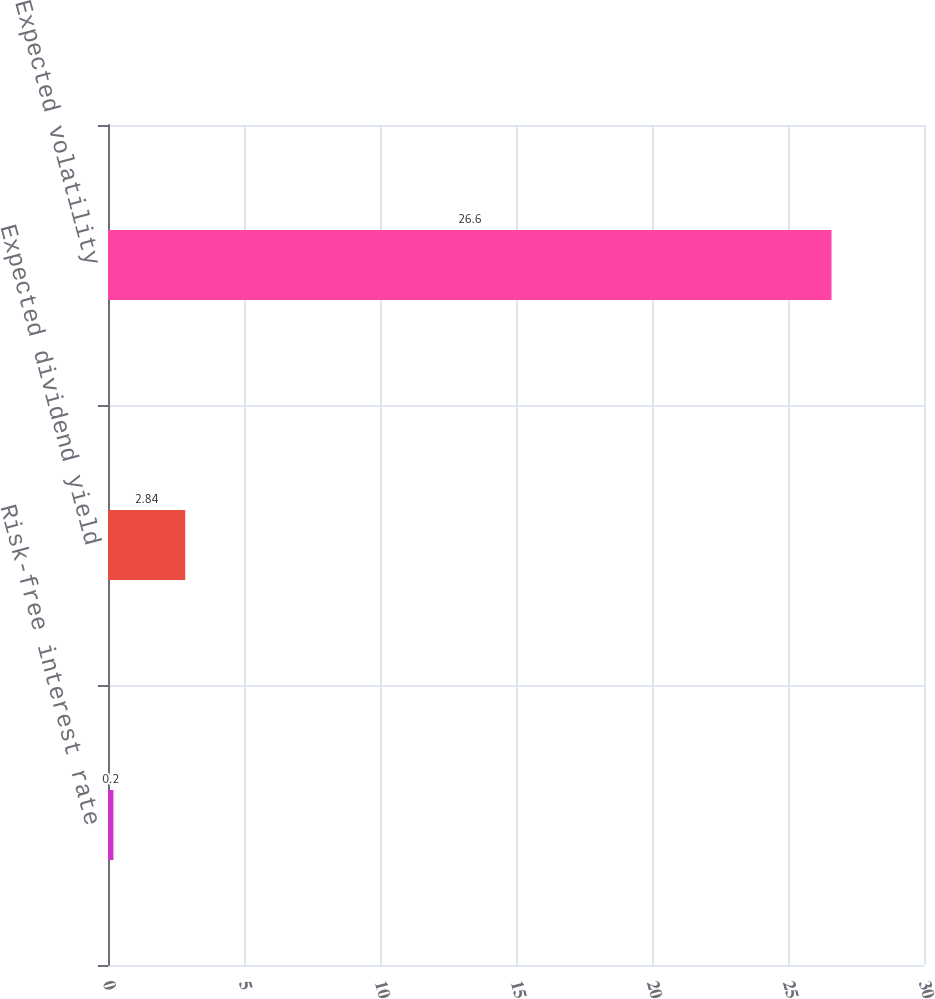Convert chart. <chart><loc_0><loc_0><loc_500><loc_500><bar_chart><fcel>Risk-free interest rate<fcel>Expected dividend yield<fcel>Expected volatility<nl><fcel>0.2<fcel>2.84<fcel>26.6<nl></chart> 